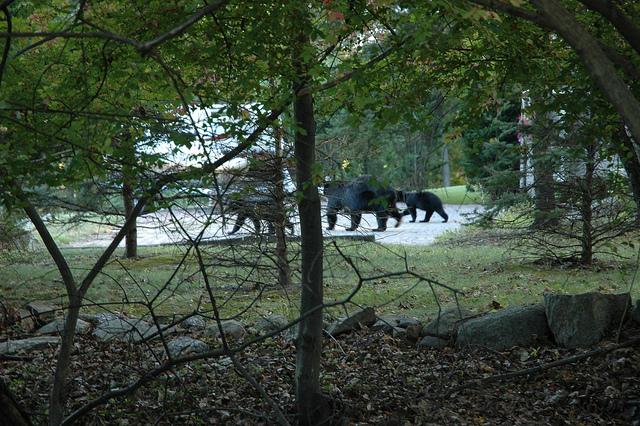What is the bear doing?
Give a very brief answer. Walking. How many bears are here?
Short answer required. 3. Are the bears trying to attack someone?
Quick response, please. No. What kind of bears are they?
Be succinct. Black. Is this bear in it's natural habitat?
Answer briefly. Yes. Is there fruit in the photo?
Keep it brief. No. Do these animals eat meat?
Be succinct. Yes. What's next to the bear?
Give a very brief answer. Trees. Three rocks are in the same shape,what shape is it?
Keep it brief. Round. Is it a winter day?
Give a very brief answer. No. Are the bears eating people?
Quick response, please. No. Can the bears get to the person holding the camera?
Concise answer only. Yes. Could this scene be in Alaska?
Write a very short answer. Yes. Are there animals in the picture?
Concise answer only. Yes. 